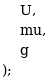<code> <loc_0><loc_0><loc_500><loc_500><_C++_>	U,
	mu,
	g
);
</code> 